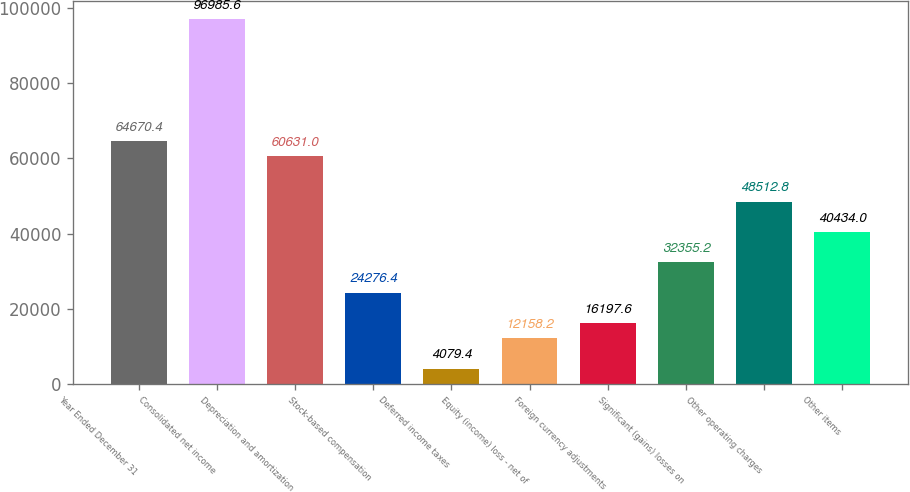Convert chart. <chart><loc_0><loc_0><loc_500><loc_500><bar_chart><fcel>Year Ended December 31<fcel>Consolidated net income<fcel>Depreciation and amortization<fcel>Stock-based compensation<fcel>Deferred income taxes<fcel>Equity (income) loss - net of<fcel>Foreign currency adjustments<fcel>Significant (gains) losses on<fcel>Other operating charges<fcel>Other items<nl><fcel>64670.4<fcel>96985.6<fcel>60631<fcel>24276.4<fcel>4079.4<fcel>12158.2<fcel>16197.6<fcel>32355.2<fcel>48512.8<fcel>40434<nl></chart> 